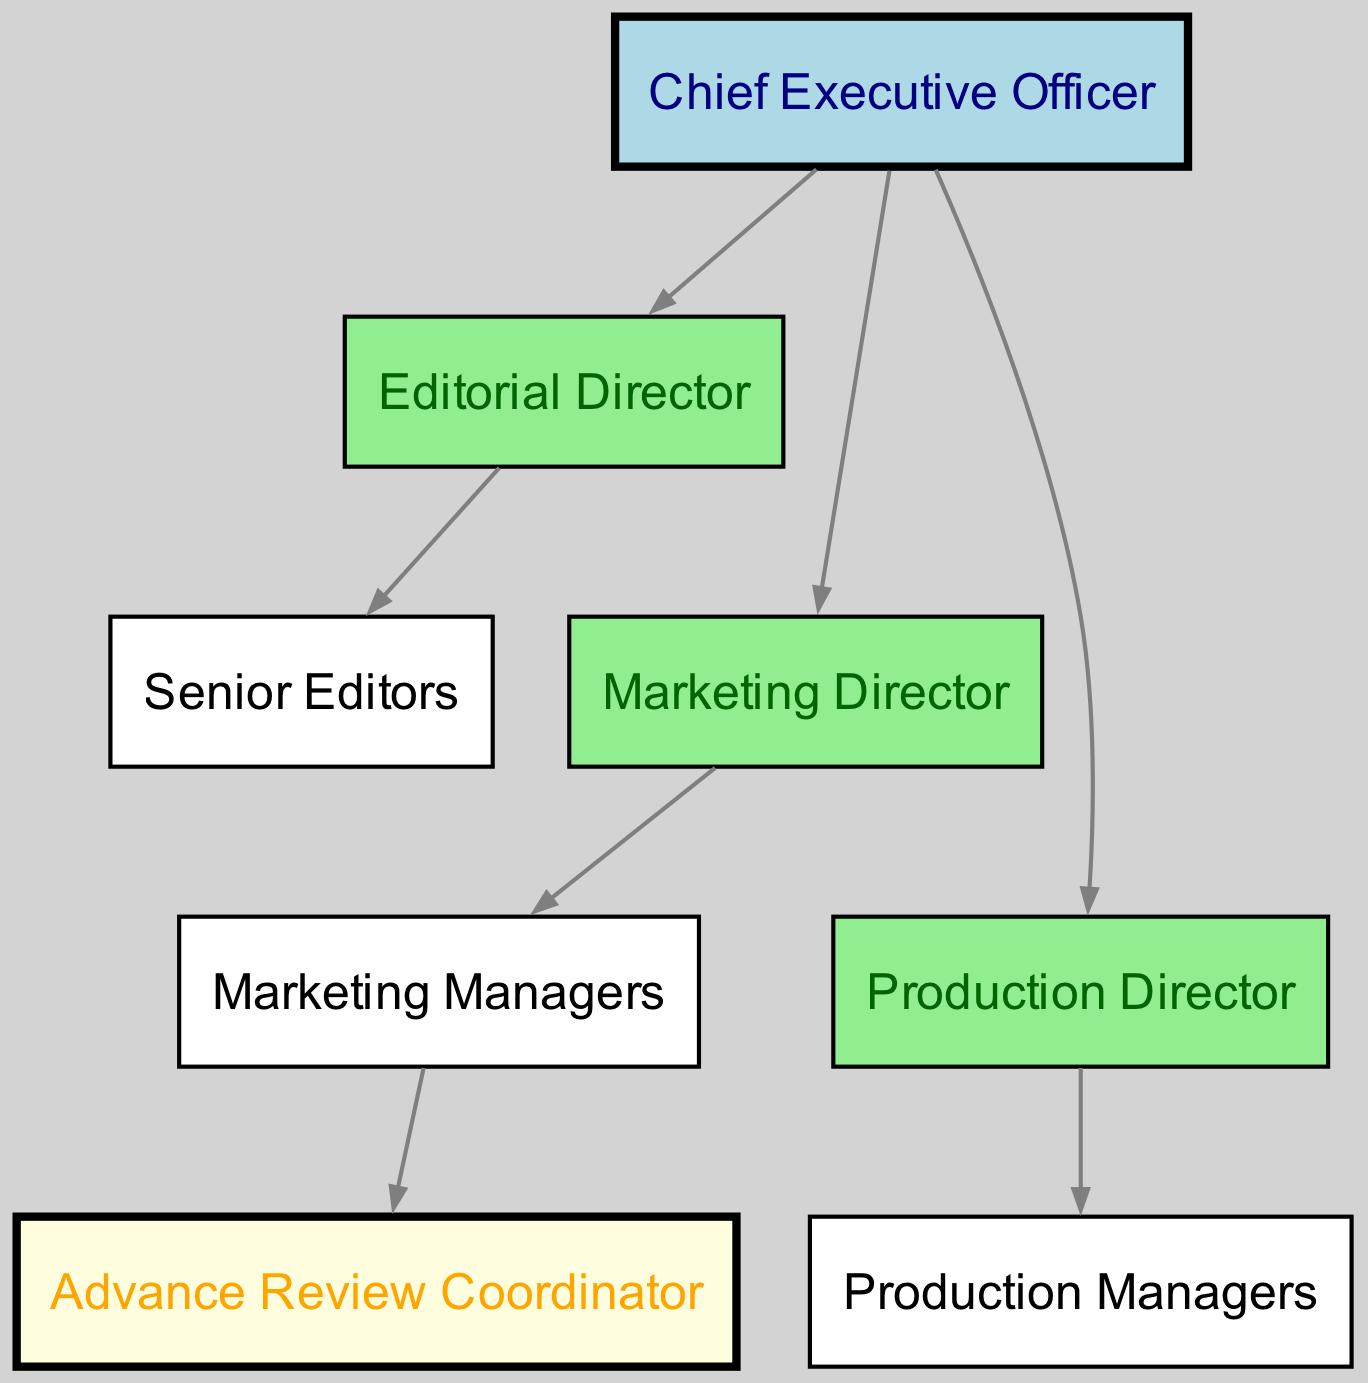What is the top position in the hierarchy? The diagram indicates that the Chief Executive Officer is at the top of the hierarchy, as all other positions report to this role.
Answer: Chief Executive Officer How many nodes are present in the diagram? By counting the individual nodes listed, there are a total of 8 distinct positions represented in the hierarchy.
Answer: 8 Who directly reports to the Chief Executive Officer? The diagram shows three roles that report directly to the Chief Executive Officer: the Editorial Director, Marketing Director, and Production Director.
Answer: Editorial Director, Marketing Director, Production Director What role is responsible for managing Advance Reviews? The Advance Review Coordinator is specifically identified in the diagram as the role that oversees advance reviews, and is subordinate to the Marketing Managers.
Answer: Advance Review Coordinator Which node has the most subordinates? The Editorial Director has multiple senior editors under their supervision, while others like the Marketing Director only oversee one position. Thus, the Editorial Director has the most subordinates in this chart.
Answer: Editorial Director How does the Marketing Director's position relate to the Advance Review Coordinator? The Advance Review Coordinator is a subordinate of the Marketing Managers, who in turn report to the Marketing Director, forming a direct hierarchy.
Answer: Marketing Director to Marketing Managers to Advance Review Coordinator What color represents the Chief Executive Officer in the diagram? The Chief Executive Officer is colored light blue in the diagram, which visually distinguishes it from other roles.
Answer: Light blue Which roles are classified under the Marketing department? The Marketing department includes the Marketing Director and the Marketing Managers, as shown in the hierarchy where the Marketing Managers report to the Marketing Director.
Answer: Marketing Director, Marketing Managers How many edges connect the Marketing Director to other nodes? The Marketing Director connects to one direct subordinate, the Marketing Managers, thus there is a single edge leading from the Marketing Director to that node.
Answer: 1 